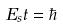Convert formula to latex. <formula><loc_0><loc_0><loc_500><loc_500>E _ { s } t = \hbar</formula> 